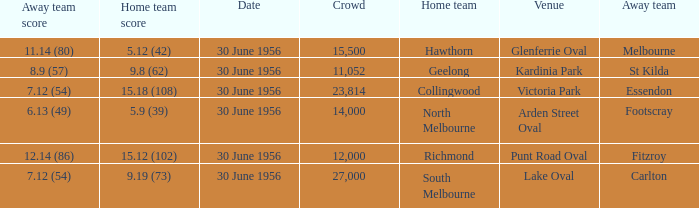What is the home team at Victoria Park with an Away team score of 7.12 (54) and more than 12,000 people? Collingwood. 